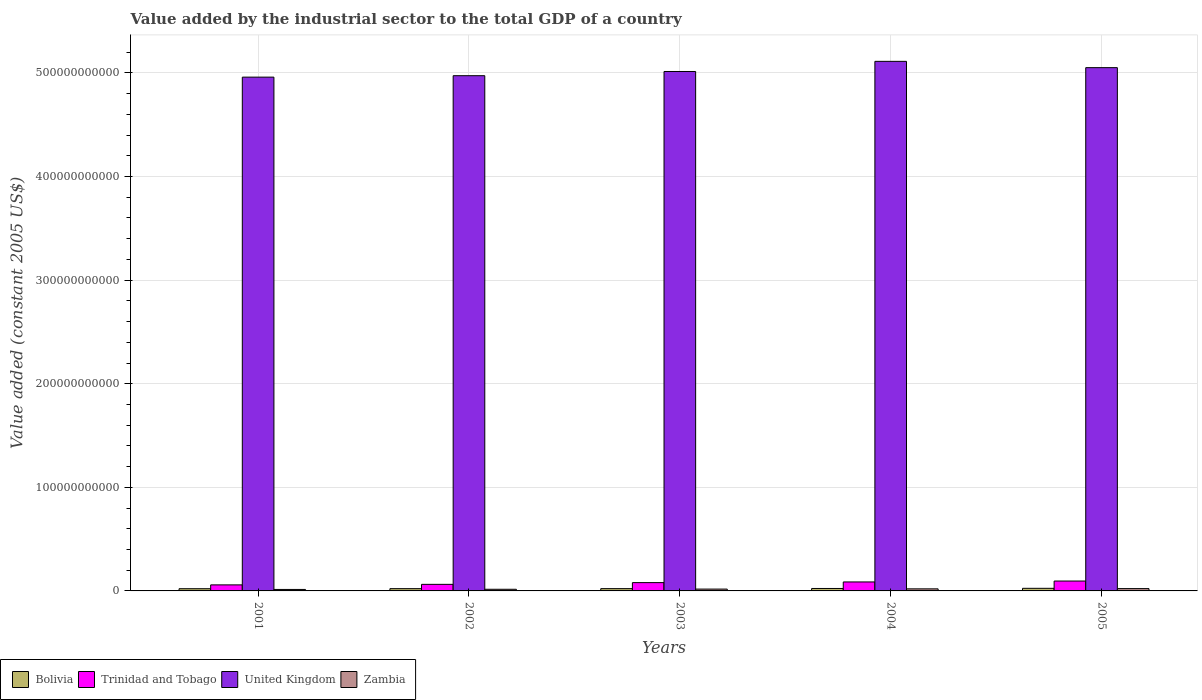How many different coloured bars are there?
Your response must be concise. 4. Are the number of bars per tick equal to the number of legend labels?
Your response must be concise. Yes. Are the number of bars on each tick of the X-axis equal?
Provide a succinct answer. Yes. How many bars are there on the 4th tick from the left?
Offer a terse response. 4. How many bars are there on the 3rd tick from the right?
Your answer should be compact. 4. In how many cases, is the number of bars for a given year not equal to the number of legend labels?
Keep it short and to the point. 0. What is the value added by the industrial sector in Zambia in 2002?
Provide a succinct answer. 1.59e+09. Across all years, what is the maximum value added by the industrial sector in Trinidad and Tobago?
Ensure brevity in your answer.  9.53e+09. Across all years, what is the minimum value added by the industrial sector in Zambia?
Keep it short and to the point. 1.43e+09. In which year was the value added by the industrial sector in Bolivia maximum?
Offer a very short reply. 2005. What is the total value added by the industrial sector in Bolivia in the graph?
Ensure brevity in your answer.  1.14e+1. What is the difference between the value added by the industrial sector in Trinidad and Tobago in 2001 and that in 2005?
Your answer should be compact. -3.71e+09. What is the difference between the value added by the industrial sector in Zambia in 2005 and the value added by the industrial sector in Trinidad and Tobago in 2004?
Make the answer very short. -6.43e+09. What is the average value added by the industrial sector in Bolivia per year?
Provide a succinct answer. 2.28e+09. In the year 2003, what is the difference between the value added by the industrial sector in Trinidad and Tobago and value added by the industrial sector in Bolivia?
Your answer should be very brief. 5.80e+09. In how many years, is the value added by the industrial sector in Bolivia greater than 260000000000 US$?
Your response must be concise. 0. What is the ratio of the value added by the industrial sector in Bolivia in 2001 to that in 2002?
Offer a terse response. 0.97. Is the value added by the industrial sector in Trinidad and Tobago in 2002 less than that in 2003?
Your response must be concise. Yes. What is the difference between the highest and the second highest value added by the industrial sector in Trinidad and Tobago?
Provide a short and direct response. 8.66e+08. What is the difference between the highest and the lowest value added by the industrial sector in United Kingdom?
Make the answer very short. 1.52e+1. What does the 2nd bar from the left in 2001 represents?
Offer a very short reply. Trinidad and Tobago. What does the 1st bar from the right in 2001 represents?
Provide a succinct answer. Zambia. How many years are there in the graph?
Your answer should be very brief. 5. What is the difference between two consecutive major ticks on the Y-axis?
Your response must be concise. 1.00e+11. Are the values on the major ticks of Y-axis written in scientific E-notation?
Offer a terse response. No. Does the graph contain any zero values?
Your answer should be compact. No. Where does the legend appear in the graph?
Offer a terse response. Bottom left. How are the legend labels stacked?
Your answer should be compact. Horizontal. What is the title of the graph?
Your response must be concise. Value added by the industrial sector to the total GDP of a country. What is the label or title of the X-axis?
Your answer should be compact. Years. What is the label or title of the Y-axis?
Your answer should be compact. Value added (constant 2005 US$). What is the Value added (constant 2005 US$) of Bolivia in 2001?
Provide a short and direct response. 2.14e+09. What is the Value added (constant 2005 US$) in Trinidad and Tobago in 2001?
Keep it short and to the point. 5.82e+09. What is the Value added (constant 2005 US$) in United Kingdom in 2001?
Offer a very short reply. 4.96e+11. What is the Value added (constant 2005 US$) of Zambia in 2001?
Ensure brevity in your answer.  1.43e+09. What is the Value added (constant 2005 US$) of Bolivia in 2002?
Make the answer very short. 2.20e+09. What is the Value added (constant 2005 US$) of Trinidad and Tobago in 2002?
Ensure brevity in your answer.  6.34e+09. What is the Value added (constant 2005 US$) of United Kingdom in 2002?
Ensure brevity in your answer.  4.97e+11. What is the Value added (constant 2005 US$) in Zambia in 2002?
Ensure brevity in your answer.  1.59e+09. What is the Value added (constant 2005 US$) in Bolivia in 2003?
Make the answer very short. 2.22e+09. What is the Value added (constant 2005 US$) in Trinidad and Tobago in 2003?
Make the answer very short. 8.02e+09. What is the Value added (constant 2005 US$) of United Kingdom in 2003?
Make the answer very short. 5.01e+11. What is the Value added (constant 2005 US$) of Zambia in 2003?
Your answer should be compact. 1.77e+09. What is the Value added (constant 2005 US$) of Bolivia in 2004?
Your response must be concise. 2.36e+09. What is the Value added (constant 2005 US$) in Trinidad and Tobago in 2004?
Your answer should be very brief. 8.67e+09. What is the Value added (constant 2005 US$) of United Kingdom in 2004?
Offer a very short reply. 5.11e+11. What is the Value added (constant 2005 US$) of Zambia in 2004?
Offer a very short reply. 2.00e+09. What is the Value added (constant 2005 US$) of Bolivia in 2005?
Your answer should be very brief. 2.51e+09. What is the Value added (constant 2005 US$) in Trinidad and Tobago in 2005?
Offer a terse response. 9.53e+09. What is the Value added (constant 2005 US$) in United Kingdom in 2005?
Provide a succinct answer. 5.05e+11. What is the Value added (constant 2005 US$) of Zambia in 2005?
Offer a terse response. 2.24e+09. Across all years, what is the maximum Value added (constant 2005 US$) in Bolivia?
Offer a terse response. 2.51e+09. Across all years, what is the maximum Value added (constant 2005 US$) of Trinidad and Tobago?
Your response must be concise. 9.53e+09. Across all years, what is the maximum Value added (constant 2005 US$) in United Kingdom?
Offer a very short reply. 5.11e+11. Across all years, what is the maximum Value added (constant 2005 US$) in Zambia?
Ensure brevity in your answer.  2.24e+09. Across all years, what is the minimum Value added (constant 2005 US$) of Bolivia?
Ensure brevity in your answer.  2.14e+09. Across all years, what is the minimum Value added (constant 2005 US$) of Trinidad and Tobago?
Your answer should be compact. 5.82e+09. Across all years, what is the minimum Value added (constant 2005 US$) of United Kingdom?
Offer a very short reply. 4.96e+11. Across all years, what is the minimum Value added (constant 2005 US$) of Zambia?
Provide a short and direct response. 1.43e+09. What is the total Value added (constant 2005 US$) in Bolivia in the graph?
Provide a short and direct response. 1.14e+1. What is the total Value added (constant 2005 US$) in Trinidad and Tobago in the graph?
Provide a short and direct response. 3.84e+1. What is the total Value added (constant 2005 US$) of United Kingdom in the graph?
Offer a terse response. 2.51e+12. What is the total Value added (constant 2005 US$) in Zambia in the graph?
Provide a succinct answer. 9.03e+09. What is the difference between the Value added (constant 2005 US$) of Bolivia in 2001 and that in 2002?
Your answer should be very brief. -5.73e+07. What is the difference between the Value added (constant 2005 US$) in Trinidad and Tobago in 2001 and that in 2002?
Offer a very short reply. -5.15e+08. What is the difference between the Value added (constant 2005 US$) in United Kingdom in 2001 and that in 2002?
Your response must be concise. -1.39e+09. What is the difference between the Value added (constant 2005 US$) of Zambia in 2001 and that in 2002?
Provide a short and direct response. -1.57e+08. What is the difference between the Value added (constant 2005 US$) of Bolivia in 2001 and that in 2003?
Keep it short and to the point. -7.70e+07. What is the difference between the Value added (constant 2005 US$) in Trinidad and Tobago in 2001 and that in 2003?
Provide a short and direct response. -2.20e+09. What is the difference between the Value added (constant 2005 US$) of United Kingdom in 2001 and that in 2003?
Keep it short and to the point. -5.45e+09. What is the difference between the Value added (constant 2005 US$) of Zambia in 2001 and that in 2003?
Give a very brief answer. -3.40e+08. What is the difference between the Value added (constant 2005 US$) of Bolivia in 2001 and that in 2004?
Your response must be concise. -2.17e+08. What is the difference between the Value added (constant 2005 US$) of Trinidad and Tobago in 2001 and that in 2004?
Offer a very short reply. -2.84e+09. What is the difference between the Value added (constant 2005 US$) of United Kingdom in 2001 and that in 2004?
Provide a short and direct response. -1.52e+1. What is the difference between the Value added (constant 2005 US$) in Zambia in 2001 and that in 2004?
Your answer should be compact. -5.65e+08. What is the difference between the Value added (constant 2005 US$) of Bolivia in 2001 and that in 2005?
Your response must be concise. -3.69e+08. What is the difference between the Value added (constant 2005 US$) of Trinidad and Tobago in 2001 and that in 2005?
Offer a terse response. -3.71e+09. What is the difference between the Value added (constant 2005 US$) in United Kingdom in 2001 and that in 2005?
Give a very brief answer. -9.16e+09. What is the difference between the Value added (constant 2005 US$) in Zambia in 2001 and that in 2005?
Your answer should be compact. -8.05e+08. What is the difference between the Value added (constant 2005 US$) in Bolivia in 2002 and that in 2003?
Offer a very short reply. -1.97e+07. What is the difference between the Value added (constant 2005 US$) of Trinidad and Tobago in 2002 and that in 2003?
Keep it short and to the point. -1.68e+09. What is the difference between the Value added (constant 2005 US$) of United Kingdom in 2002 and that in 2003?
Offer a very short reply. -4.06e+09. What is the difference between the Value added (constant 2005 US$) in Zambia in 2002 and that in 2003?
Give a very brief answer. -1.83e+08. What is the difference between the Value added (constant 2005 US$) of Bolivia in 2002 and that in 2004?
Offer a terse response. -1.59e+08. What is the difference between the Value added (constant 2005 US$) of Trinidad and Tobago in 2002 and that in 2004?
Your answer should be compact. -2.33e+09. What is the difference between the Value added (constant 2005 US$) of United Kingdom in 2002 and that in 2004?
Your response must be concise. -1.38e+1. What is the difference between the Value added (constant 2005 US$) of Zambia in 2002 and that in 2004?
Ensure brevity in your answer.  -4.07e+08. What is the difference between the Value added (constant 2005 US$) of Bolivia in 2002 and that in 2005?
Ensure brevity in your answer.  -3.12e+08. What is the difference between the Value added (constant 2005 US$) of Trinidad and Tobago in 2002 and that in 2005?
Provide a succinct answer. -3.19e+09. What is the difference between the Value added (constant 2005 US$) of United Kingdom in 2002 and that in 2005?
Offer a terse response. -7.77e+09. What is the difference between the Value added (constant 2005 US$) of Zambia in 2002 and that in 2005?
Provide a succinct answer. -6.48e+08. What is the difference between the Value added (constant 2005 US$) of Bolivia in 2003 and that in 2004?
Your answer should be very brief. -1.40e+08. What is the difference between the Value added (constant 2005 US$) of Trinidad and Tobago in 2003 and that in 2004?
Give a very brief answer. -6.47e+08. What is the difference between the Value added (constant 2005 US$) of United Kingdom in 2003 and that in 2004?
Offer a very short reply. -9.79e+09. What is the difference between the Value added (constant 2005 US$) of Zambia in 2003 and that in 2004?
Offer a very short reply. -2.24e+08. What is the difference between the Value added (constant 2005 US$) of Bolivia in 2003 and that in 2005?
Keep it short and to the point. -2.92e+08. What is the difference between the Value added (constant 2005 US$) in Trinidad and Tobago in 2003 and that in 2005?
Offer a terse response. -1.51e+09. What is the difference between the Value added (constant 2005 US$) in United Kingdom in 2003 and that in 2005?
Offer a very short reply. -3.71e+09. What is the difference between the Value added (constant 2005 US$) in Zambia in 2003 and that in 2005?
Provide a succinct answer. -4.65e+08. What is the difference between the Value added (constant 2005 US$) of Bolivia in 2004 and that in 2005?
Your answer should be very brief. -1.53e+08. What is the difference between the Value added (constant 2005 US$) in Trinidad and Tobago in 2004 and that in 2005?
Provide a short and direct response. -8.66e+08. What is the difference between the Value added (constant 2005 US$) in United Kingdom in 2004 and that in 2005?
Provide a succinct answer. 6.08e+09. What is the difference between the Value added (constant 2005 US$) of Zambia in 2004 and that in 2005?
Offer a terse response. -2.41e+08. What is the difference between the Value added (constant 2005 US$) in Bolivia in 2001 and the Value added (constant 2005 US$) in Trinidad and Tobago in 2002?
Ensure brevity in your answer.  -4.20e+09. What is the difference between the Value added (constant 2005 US$) of Bolivia in 2001 and the Value added (constant 2005 US$) of United Kingdom in 2002?
Offer a terse response. -4.95e+11. What is the difference between the Value added (constant 2005 US$) of Bolivia in 2001 and the Value added (constant 2005 US$) of Zambia in 2002?
Ensure brevity in your answer.  5.50e+08. What is the difference between the Value added (constant 2005 US$) in Trinidad and Tobago in 2001 and the Value added (constant 2005 US$) in United Kingdom in 2002?
Offer a very short reply. -4.92e+11. What is the difference between the Value added (constant 2005 US$) of Trinidad and Tobago in 2001 and the Value added (constant 2005 US$) of Zambia in 2002?
Your response must be concise. 4.24e+09. What is the difference between the Value added (constant 2005 US$) in United Kingdom in 2001 and the Value added (constant 2005 US$) in Zambia in 2002?
Offer a very short reply. 4.94e+11. What is the difference between the Value added (constant 2005 US$) in Bolivia in 2001 and the Value added (constant 2005 US$) in Trinidad and Tobago in 2003?
Offer a very short reply. -5.88e+09. What is the difference between the Value added (constant 2005 US$) in Bolivia in 2001 and the Value added (constant 2005 US$) in United Kingdom in 2003?
Your response must be concise. -4.99e+11. What is the difference between the Value added (constant 2005 US$) in Bolivia in 2001 and the Value added (constant 2005 US$) in Zambia in 2003?
Keep it short and to the point. 3.67e+08. What is the difference between the Value added (constant 2005 US$) in Trinidad and Tobago in 2001 and the Value added (constant 2005 US$) in United Kingdom in 2003?
Provide a short and direct response. -4.96e+11. What is the difference between the Value added (constant 2005 US$) of Trinidad and Tobago in 2001 and the Value added (constant 2005 US$) of Zambia in 2003?
Ensure brevity in your answer.  4.05e+09. What is the difference between the Value added (constant 2005 US$) in United Kingdom in 2001 and the Value added (constant 2005 US$) in Zambia in 2003?
Provide a short and direct response. 4.94e+11. What is the difference between the Value added (constant 2005 US$) of Bolivia in 2001 and the Value added (constant 2005 US$) of Trinidad and Tobago in 2004?
Give a very brief answer. -6.53e+09. What is the difference between the Value added (constant 2005 US$) in Bolivia in 2001 and the Value added (constant 2005 US$) in United Kingdom in 2004?
Give a very brief answer. -5.09e+11. What is the difference between the Value added (constant 2005 US$) in Bolivia in 2001 and the Value added (constant 2005 US$) in Zambia in 2004?
Keep it short and to the point. 1.43e+08. What is the difference between the Value added (constant 2005 US$) in Trinidad and Tobago in 2001 and the Value added (constant 2005 US$) in United Kingdom in 2004?
Ensure brevity in your answer.  -5.05e+11. What is the difference between the Value added (constant 2005 US$) in Trinidad and Tobago in 2001 and the Value added (constant 2005 US$) in Zambia in 2004?
Keep it short and to the point. 3.83e+09. What is the difference between the Value added (constant 2005 US$) in United Kingdom in 2001 and the Value added (constant 2005 US$) in Zambia in 2004?
Provide a short and direct response. 4.94e+11. What is the difference between the Value added (constant 2005 US$) in Bolivia in 2001 and the Value added (constant 2005 US$) in Trinidad and Tobago in 2005?
Make the answer very short. -7.39e+09. What is the difference between the Value added (constant 2005 US$) in Bolivia in 2001 and the Value added (constant 2005 US$) in United Kingdom in 2005?
Offer a terse response. -5.03e+11. What is the difference between the Value added (constant 2005 US$) in Bolivia in 2001 and the Value added (constant 2005 US$) in Zambia in 2005?
Provide a succinct answer. -9.78e+07. What is the difference between the Value added (constant 2005 US$) of Trinidad and Tobago in 2001 and the Value added (constant 2005 US$) of United Kingdom in 2005?
Your answer should be very brief. -4.99e+11. What is the difference between the Value added (constant 2005 US$) in Trinidad and Tobago in 2001 and the Value added (constant 2005 US$) in Zambia in 2005?
Your answer should be compact. 3.59e+09. What is the difference between the Value added (constant 2005 US$) in United Kingdom in 2001 and the Value added (constant 2005 US$) in Zambia in 2005?
Offer a very short reply. 4.94e+11. What is the difference between the Value added (constant 2005 US$) of Bolivia in 2002 and the Value added (constant 2005 US$) of Trinidad and Tobago in 2003?
Offer a terse response. -5.82e+09. What is the difference between the Value added (constant 2005 US$) in Bolivia in 2002 and the Value added (constant 2005 US$) in United Kingdom in 2003?
Offer a very short reply. -4.99e+11. What is the difference between the Value added (constant 2005 US$) in Bolivia in 2002 and the Value added (constant 2005 US$) in Zambia in 2003?
Your response must be concise. 4.25e+08. What is the difference between the Value added (constant 2005 US$) of Trinidad and Tobago in 2002 and the Value added (constant 2005 US$) of United Kingdom in 2003?
Ensure brevity in your answer.  -4.95e+11. What is the difference between the Value added (constant 2005 US$) of Trinidad and Tobago in 2002 and the Value added (constant 2005 US$) of Zambia in 2003?
Provide a short and direct response. 4.57e+09. What is the difference between the Value added (constant 2005 US$) of United Kingdom in 2002 and the Value added (constant 2005 US$) of Zambia in 2003?
Your response must be concise. 4.96e+11. What is the difference between the Value added (constant 2005 US$) in Bolivia in 2002 and the Value added (constant 2005 US$) in Trinidad and Tobago in 2004?
Give a very brief answer. -6.47e+09. What is the difference between the Value added (constant 2005 US$) in Bolivia in 2002 and the Value added (constant 2005 US$) in United Kingdom in 2004?
Give a very brief answer. -5.09e+11. What is the difference between the Value added (constant 2005 US$) of Bolivia in 2002 and the Value added (constant 2005 US$) of Zambia in 2004?
Ensure brevity in your answer.  2.00e+08. What is the difference between the Value added (constant 2005 US$) in Trinidad and Tobago in 2002 and the Value added (constant 2005 US$) in United Kingdom in 2004?
Your response must be concise. -5.05e+11. What is the difference between the Value added (constant 2005 US$) of Trinidad and Tobago in 2002 and the Value added (constant 2005 US$) of Zambia in 2004?
Give a very brief answer. 4.34e+09. What is the difference between the Value added (constant 2005 US$) in United Kingdom in 2002 and the Value added (constant 2005 US$) in Zambia in 2004?
Offer a very short reply. 4.95e+11. What is the difference between the Value added (constant 2005 US$) in Bolivia in 2002 and the Value added (constant 2005 US$) in Trinidad and Tobago in 2005?
Your response must be concise. -7.34e+09. What is the difference between the Value added (constant 2005 US$) of Bolivia in 2002 and the Value added (constant 2005 US$) of United Kingdom in 2005?
Your answer should be compact. -5.03e+11. What is the difference between the Value added (constant 2005 US$) in Bolivia in 2002 and the Value added (constant 2005 US$) in Zambia in 2005?
Offer a terse response. -4.05e+07. What is the difference between the Value added (constant 2005 US$) in Trinidad and Tobago in 2002 and the Value added (constant 2005 US$) in United Kingdom in 2005?
Your answer should be very brief. -4.99e+11. What is the difference between the Value added (constant 2005 US$) in Trinidad and Tobago in 2002 and the Value added (constant 2005 US$) in Zambia in 2005?
Your response must be concise. 4.10e+09. What is the difference between the Value added (constant 2005 US$) in United Kingdom in 2002 and the Value added (constant 2005 US$) in Zambia in 2005?
Your answer should be very brief. 4.95e+11. What is the difference between the Value added (constant 2005 US$) of Bolivia in 2003 and the Value added (constant 2005 US$) of Trinidad and Tobago in 2004?
Ensure brevity in your answer.  -6.45e+09. What is the difference between the Value added (constant 2005 US$) in Bolivia in 2003 and the Value added (constant 2005 US$) in United Kingdom in 2004?
Offer a terse response. -5.09e+11. What is the difference between the Value added (constant 2005 US$) in Bolivia in 2003 and the Value added (constant 2005 US$) in Zambia in 2004?
Provide a short and direct response. 2.20e+08. What is the difference between the Value added (constant 2005 US$) in Trinidad and Tobago in 2003 and the Value added (constant 2005 US$) in United Kingdom in 2004?
Ensure brevity in your answer.  -5.03e+11. What is the difference between the Value added (constant 2005 US$) in Trinidad and Tobago in 2003 and the Value added (constant 2005 US$) in Zambia in 2004?
Give a very brief answer. 6.02e+09. What is the difference between the Value added (constant 2005 US$) in United Kingdom in 2003 and the Value added (constant 2005 US$) in Zambia in 2004?
Your answer should be compact. 4.99e+11. What is the difference between the Value added (constant 2005 US$) in Bolivia in 2003 and the Value added (constant 2005 US$) in Trinidad and Tobago in 2005?
Provide a succinct answer. -7.32e+09. What is the difference between the Value added (constant 2005 US$) in Bolivia in 2003 and the Value added (constant 2005 US$) in United Kingdom in 2005?
Offer a very short reply. -5.03e+11. What is the difference between the Value added (constant 2005 US$) of Bolivia in 2003 and the Value added (constant 2005 US$) of Zambia in 2005?
Make the answer very short. -2.08e+07. What is the difference between the Value added (constant 2005 US$) of Trinidad and Tobago in 2003 and the Value added (constant 2005 US$) of United Kingdom in 2005?
Your response must be concise. -4.97e+11. What is the difference between the Value added (constant 2005 US$) in Trinidad and Tobago in 2003 and the Value added (constant 2005 US$) in Zambia in 2005?
Provide a short and direct response. 5.78e+09. What is the difference between the Value added (constant 2005 US$) of United Kingdom in 2003 and the Value added (constant 2005 US$) of Zambia in 2005?
Provide a short and direct response. 4.99e+11. What is the difference between the Value added (constant 2005 US$) of Bolivia in 2004 and the Value added (constant 2005 US$) of Trinidad and Tobago in 2005?
Offer a terse response. -7.18e+09. What is the difference between the Value added (constant 2005 US$) of Bolivia in 2004 and the Value added (constant 2005 US$) of United Kingdom in 2005?
Your response must be concise. -5.03e+11. What is the difference between the Value added (constant 2005 US$) in Bolivia in 2004 and the Value added (constant 2005 US$) in Zambia in 2005?
Keep it short and to the point. 1.19e+08. What is the difference between the Value added (constant 2005 US$) in Trinidad and Tobago in 2004 and the Value added (constant 2005 US$) in United Kingdom in 2005?
Your response must be concise. -4.96e+11. What is the difference between the Value added (constant 2005 US$) of Trinidad and Tobago in 2004 and the Value added (constant 2005 US$) of Zambia in 2005?
Offer a terse response. 6.43e+09. What is the difference between the Value added (constant 2005 US$) in United Kingdom in 2004 and the Value added (constant 2005 US$) in Zambia in 2005?
Give a very brief answer. 5.09e+11. What is the average Value added (constant 2005 US$) in Bolivia per year?
Keep it short and to the point. 2.28e+09. What is the average Value added (constant 2005 US$) in Trinidad and Tobago per year?
Provide a succinct answer. 7.68e+09. What is the average Value added (constant 2005 US$) of United Kingdom per year?
Your answer should be very brief. 5.02e+11. What is the average Value added (constant 2005 US$) in Zambia per year?
Your answer should be very brief. 1.81e+09. In the year 2001, what is the difference between the Value added (constant 2005 US$) of Bolivia and Value added (constant 2005 US$) of Trinidad and Tobago?
Offer a terse response. -3.68e+09. In the year 2001, what is the difference between the Value added (constant 2005 US$) of Bolivia and Value added (constant 2005 US$) of United Kingdom?
Make the answer very short. -4.94e+11. In the year 2001, what is the difference between the Value added (constant 2005 US$) of Bolivia and Value added (constant 2005 US$) of Zambia?
Keep it short and to the point. 7.08e+08. In the year 2001, what is the difference between the Value added (constant 2005 US$) of Trinidad and Tobago and Value added (constant 2005 US$) of United Kingdom?
Your answer should be very brief. -4.90e+11. In the year 2001, what is the difference between the Value added (constant 2005 US$) in Trinidad and Tobago and Value added (constant 2005 US$) in Zambia?
Keep it short and to the point. 4.39e+09. In the year 2001, what is the difference between the Value added (constant 2005 US$) in United Kingdom and Value added (constant 2005 US$) in Zambia?
Offer a very short reply. 4.95e+11. In the year 2002, what is the difference between the Value added (constant 2005 US$) in Bolivia and Value added (constant 2005 US$) in Trinidad and Tobago?
Keep it short and to the point. -4.14e+09. In the year 2002, what is the difference between the Value added (constant 2005 US$) of Bolivia and Value added (constant 2005 US$) of United Kingdom?
Make the answer very short. -4.95e+11. In the year 2002, what is the difference between the Value added (constant 2005 US$) of Bolivia and Value added (constant 2005 US$) of Zambia?
Ensure brevity in your answer.  6.08e+08. In the year 2002, what is the difference between the Value added (constant 2005 US$) of Trinidad and Tobago and Value added (constant 2005 US$) of United Kingdom?
Your answer should be compact. -4.91e+11. In the year 2002, what is the difference between the Value added (constant 2005 US$) in Trinidad and Tobago and Value added (constant 2005 US$) in Zambia?
Provide a short and direct response. 4.75e+09. In the year 2002, what is the difference between the Value added (constant 2005 US$) of United Kingdom and Value added (constant 2005 US$) of Zambia?
Give a very brief answer. 4.96e+11. In the year 2003, what is the difference between the Value added (constant 2005 US$) of Bolivia and Value added (constant 2005 US$) of Trinidad and Tobago?
Provide a short and direct response. -5.80e+09. In the year 2003, what is the difference between the Value added (constant 2005 US$) of Bolivia and Value added (constant 2005 US$) of United Kingdom?
Provide a succinct answer. -4.99e+11. In the year 2003, what is the difference between the Value added (constant 2005 US$) in Bolivia and Value added (constant 2005 US$) in Zambia?
Keep it short and to the point. 4.44e+08. In the year 2003, what is the difference between the Value added (constant 2005 US$) in Trinidad and Tobago and Value added (constant 2005 US$) in United Kingdom?
Ensure brevity in your answer.  -4.93e+11. In the year 2003, what is the difference between the Value added (constant 2005 US$) of Trinidad and Tobago and Value added (constant 2005 US$) of Zambia?
Your response must be concise. 6.25e+09. In the year 2003, what is the difference between the Value added (constant 2005 US$) of United Kingdom and Value added (constant 2005 US$) of Zambia?
Offer a very short reply. 5.00e+11. In the year 2004, what is the difference between the Value added (constant 2005 US$) in Bolivia and Value added (constant 2005 US$) in Trinidad and Tobago?
Your answer should be very brief. -6.31e+09. In the year 2004, what is the difference between the Value added (constant 2005 US$) of Bolivia and Value added (constant 2005 US$) of United Kingdom?
Make the answer very short. -5.09e+11. In the year 2004, what is the difference between the Value added (constant 2005 US$) in Bolivia and Value added (constant 2005 US$) in Zambia?
Offer a terse response. 3.60e+08. In the year 2004, what is the difference between the Value added (constant 2005 US$) of Trinidad and Tobago and Value added (constant 2005 US$) of United Kingdom?
Your answer should be very brief. -5.03e+11. In the year 2004, what is the difference between the Value added (constant 2005 US$) in Trinidad and Tobago and Value added (constant 2005 US$) in Zambia?
Keep it short and to the point. 6.67e+09. In the year 2004, what is the difference between the Value added (constant 2005 US$) in United Kingdom and Value added (constant 2005 US$) in Zambia?
Keep it short and to the point. 5.09e+11. In the year 2005, what is the difference between the Value added (constant 2005 US$) in Bolivia and Value added (constant 2005 US$) in Trinidad and Tobago?
Offer a terse response. -7.02e+09. In the year 2005, what is the difference between the Value added (constant 2005 US$) in Bolivia and Value added (constant 2005 US$) in United Kingdom?
Offer a terse response. -5.03e+11. In the year 2005, what is the difference between the Value added (constant 2005 US$) in Bolivia and Value added (constant 2005 US$) in Zambia?
Keep it short and to the point. 2.71e+08. In the year 2005, what is the difference between the Value added (constant 2005 US$) in Trinidad and Tobago and Value added (constant 2005 US$) in United Kingdom?
Provide a succinct answer. -4.96e+11. In the year 2005, what is the difference between the Value added (constant 2005 US$) in Trinidad and Tobago and Value added (constant 2005 US$) in Zambia?
Make the answer very short. 7.30e+09. In the year 2005, what is the difference between the Value added (constant 2005 US$) in United Kingdom and Value added (constant 2005 US$) in Zambia?
Make the answer very short. 5.03e+11. What is the ratio of the Value added (constant 2005 US$) in Bolivia in 2001 to that in 2002?
Provide a short and direct response. 0.97. What is the ratio of the Value added (constant 2005 US$) in Trinidad and Tobago in 2001 to that in 2002?
Your answer should be compact. 0.92. What is the ratio of the Value added (constant 2005 US$) in United Kingdom in 2001 to that in 2002?
Provide a short and direct response. 1. What is the ratio of the Value added (constant 2005 US$) of Zambia in 2001 to that in 2002?
Your response must be concise. 0.9. What is the ratio of the Value added (constant 2005 US$) in Bolivia in 2001 to that in 2003?
Provide a succinct answer. 0.97. What is the ratio of the Value added (constant 2005 US$) in Trinidad and Tobago in 2001 to that in 2003?
Offer a very short reply. 0.73. What is the ratio of the Value added (constant 2005 US$) in United Kingdom in 2001 to that in 2003?
Your response must be concise. 0.99. What is the ratio of the Value added (constant 2005 US$) in Zambia in 2001 to that in 2003?
Give a very brief answer. 0.81. What is the ratio of the Value added (constant 2005 US$) in Bolivia in 2001 to that in 2004?
Keep it short and to the point. 0.91. What is the ratio of the Value added (constant 2005 US$) in Trinidad and Tobago in 2001 to that in 2004?
Offer a very short reply. 0.67. What is the ratio of the Value added (constant 2005 US$) in United Kingdom in 2001 to that in 2004?
Your response must be concise. 0.97. What is the ratio of the Value added (constant 2005 US$) in Zambia in 2001 to that in 2004?
Your response must be concise. 0.72. What is the ratio of the Value added (constant 2005 US$) of Bolivia in 2001 to that in 2005?
Offer a terse response. 0.85. What is the ratio of the Value added (constant 2005 US$) of Trinidad and Tobago in 2001 to that in 2005?
Your answer should be very brief. 0.61. What is the ratio of the Value added (constant 2005 US$) of United Kingdom in 2001 to that in 2005?
Keep it short and to the point. 0.98. What is the ratio of the Value added (constant 2005 US$) in Zambia in 2001 to that in 2005?
Make the answer very short. 0.64. What is the ratio of the Value added (constant 2005 US$) of Bolivia in 2002 to that in 2003?
Keep it short and to the point. 0.99. What is the ratio of the Value added (constant 2005 US$) in Trinidad and Tobago in 2002 to that in 2003?
Offer a very short reply. 0.79. What is the ratio of the Value added (constant 2005 US$) in Zambia in 2002 to that in 2003?
Your answer should be very brief. 0.9. What is the ratio of the Value added (constant 2005 US$) of Bolivia in 2002 to that in 2004?
Give a very brief answer. 0.93. What is the ratio of the Value added (constant 2005 US$) of Trinidad and Tobago in 2002 to that in 2004?
Give a very brief answer. 0.73. What is the ratio of the Value added (constant 2005 US$) of United Kingdom in 2002 to that in 2004?
Your response must be concise. 0.97. What is the ratio of the Value added (constant 2005 US$) in Zambia in 2002 to that in 2004?
Make the answer very short. 0.8. What is the ratio of the Value added (constant 2005 US$) of Bolivia in 2002 to that in 2005?
Provide a succinct answer. 0.88. What is the ratio of the Value added (constant 2005 US$) in Trinidad and Tobago in 2002 to that in 2005?
Offer a terse response. 0.66. What is the ratio of the Value added (constant 2005 US$) in United Kingdom in 2002 to that in 2005?
Offer a terse response. 0.98. What is the ratio of the Value added (constant 2005 US$) of Zambia in 2002 to that in 2005?
Offer a terse response. 0.71. What is the ratio of the Value added (constant 2005 US$) of Bolivia in 2003 to that in 2004?
Ensure brevity in your answer.  0.94. What is the ratio of the Value added (constant 2005 US$) of Trinidad and Tobago in 2003 to that in 2004?
Your answer should be very brief. 0.93. What is the ratio of the Value added (constant 2005 US$) in United Kingdom in 2003 to that in 2004?
Provide a short and direct response. 0.98. What is the ratio of the Value added (constant 2005 US$) of Zambia in 2003 to that in 2004?
Your answer should be compact. 0.89. What is the ratio of the Value added (constant 2005 US$) of Bolivia in 2003 to that in 2005?
Your answer should be compact. 0.88. What is the ratio of the Value added (constant 2005 US$) in Trinidad and Tobago in 2003 to that in 2005?
Your answer should be compact. 0.84. What is the ratio of the Value added (constant 2005 US$) in United Kingdom in 2003 to that in 2005?
Your answer should be compact. 0.99. What is the ratio of the Value added (constant 2005 US$) in Zambia in 2003 to that in 2005?
Make the answer very short. 0.79. What is the ratio of the Value added (constant 2005 US$) in Bolivia in 2004 to that in 2005?
Your answer should be very brief. 0.94. What is the ratio of the Value added (constant 2005 US$) in Trinidad and Tobago in 2004 to that in 2005?
Your answer should be very brief. 0.91. What is the ratio of the Value added (constant 2005 US$) in Zambia in 2004 to that in 2005?
Offer a very short reply. 0.89. What is the difference between the highest and the second highest Value added (constant 2005 US$) in Bolivia?
Offer a terse response. 1.53e+08. What is the difference between the highest and the second highest Value added (constant 2005 US$) of Trinidad and Tobago?
Ensure brevity in your answer.  8.66e+08. What is the difference between the highest and the second highest Value added (constant 2005 US$) of United Kingdom?
Your response must be concise. 6.08e+09. What is the difference between the highest and the second highest Value added (constant 2005 US$) in Zambia?
Keep it short and to the point. 2.41e+08. What is the difference between the highest and the lowest Value added (constant 2005 US$) of Bolivia?
Make the answer very short. 3.69e+08. What is the difference between the highest and the lowest Value added (constant 2005 US$) in Trinidad and Tobago?
Offer a very short reply. 3.71e+09. What is the difference between the highest and the lowest Value added (constant 2005 US$) of United Kingdom?
Provide a succinct answer. 1.52e+1. What is the difference between the highest and the lowest Value added (constant 2005 US$) in Zambia?
Make the answer very short. 8.05e+08. 